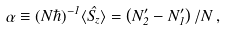<formula> <loc_0><loc_0><loc_500><loc_500>\alpha \equiv ( N \hbar { ) } ^ { - 1 } \langle \hat { S _ { z } } \rangle = \left ( N _ { 2 } ^ { \prime } - N _ { 1 } ^ { \prime } \right ) / N \, ,</formula> 